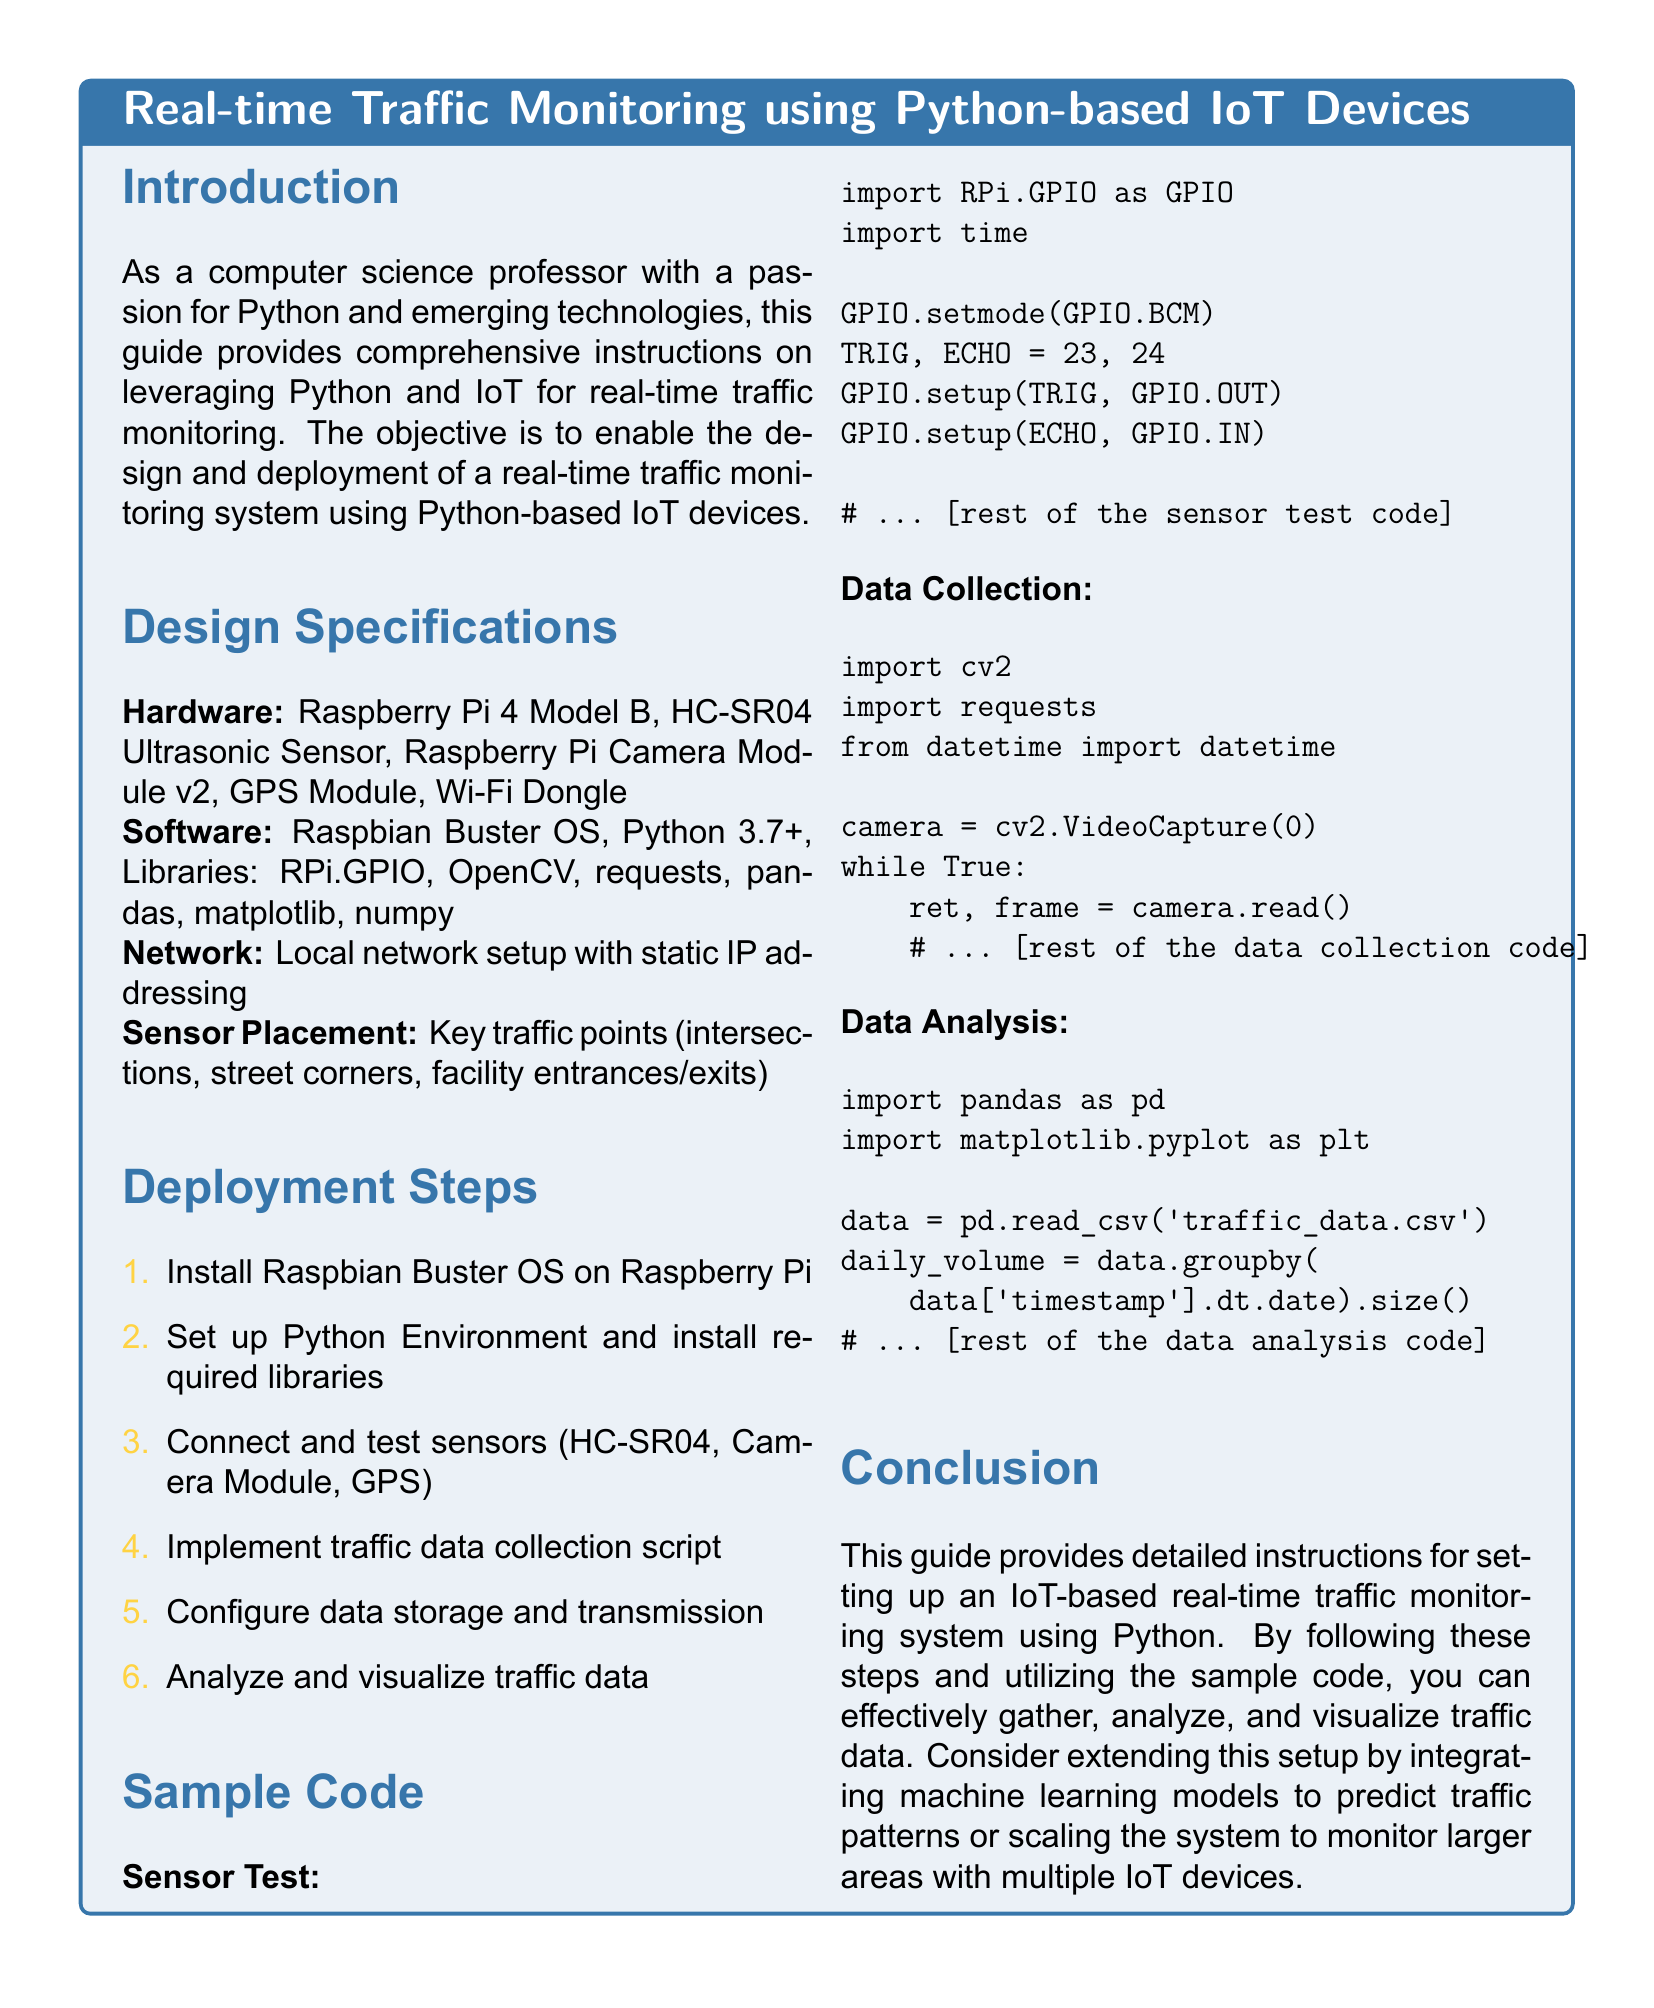what is the primary objective of the guide? The primary objective is to enable the design and deployment of a real-time traffic monitoring system using Python-based IoT devices.
Answer: design and deployment of a real-time traffic monitoring system what hardware is used in this project? The hardware specifications include Raspberry Pi 4 Model B, HC-SR04 Ultrasonic Sensor, Raspberry Pi Camera Module v2, GPS Module, and Wi-Fi Dongle.
Answer: Raspberry Pi 4 Model B, HC-SR04 Ultrasonic Sensor, Raspberry Pi Camera Module v2, GPS Module, Wi-Fi Dongle how many software libraries are listed in the design specifications? The design specifies seven libraries including RPi.GPIO, OpenCV, requests, pandas, matplotlib, and numpy.
Answer: seven which operating system is recommended for the Raspberry Pi? The recommended operating system is Raspbian Buster OS.
Answer: Raspbian Buster OS what is the first deployment step? The first deployment step is to install Raspbian Buster OS on Raspberry Pi.
Answer: install Raspbian Buster OS on Raspberry Pi what is the purpose of the Python code provided in the document? The purpose of the code is to test sensors, collect traffic data, and analyze it.
Answer: test sensors, collect traffic data, and analyze it what can be extended after setting up the IoT-based system? The setup can be extended by integrating machine learning models to predict traffic patterns.
Answer: integrating machine learning models to predict traffic patterns how does the document categorize the information presented? The information is categorized into sections such as Introduction, Design Specifications, Deployment Steps, Sample Code, and Conclusion.
Answer: sections such as Introduction, Design Specifications, Deployment Steps, Sample Code, and Conclusion 